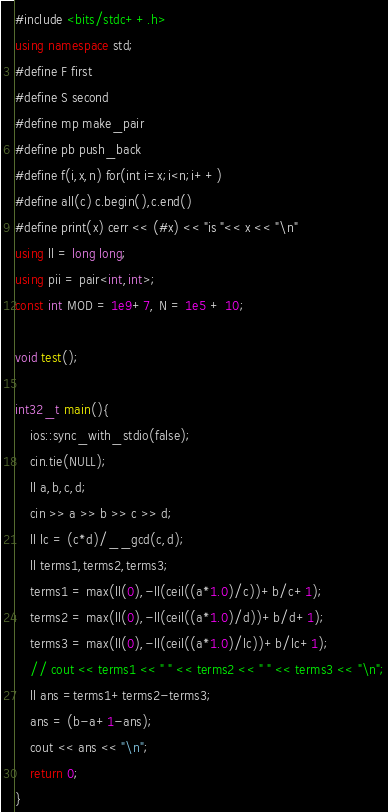Convert code to text. <code><loc_0><loc_0><loc_500><loc_500><_C++_>#include <bits/stdc++.h>
using namespace std;
#define F first
#define S second
#define mp make_pair
#define pb push_back
#define f(i,x,n) for(int i=x;i<n;i++)
#define all(c) c.begin(),c.end()
#define print(x) cerr << (#x) << "is "<< x << "\n"
using ll = long long;
using pii = pair<int,int>;
const int MOD = 1e9+7, N = 1e5 + 10;

void test();

int32_t main(){
	ios::sync_with_stdio(false);
	cin.tie(NULL);
	ll a,b,c,d;
	cin >> a >> b >> c >> d;
	ll lc = (c*d)/__gcd(c,d);
	ll terms1,terms2,terms3;
	terms1 = max(ll(0),-ll(ceil((a*1.0)/c))+b/c+1);
	terms2 = max(ll(0),-ll(ceil((a*1.0)/d))+b/d+1);
	terms3 = max(ll(0),-ll(ceil((a*1.0)/lc))+b/lc+1);
	// cout << terms1 << " " << terms2 << " " << terms3 << "\n";
	ll ans =terms1+terms2-terms3;
	ans = (b-a+1-ans);
	cout << ans << "\n";
	return 0;
}</code> 